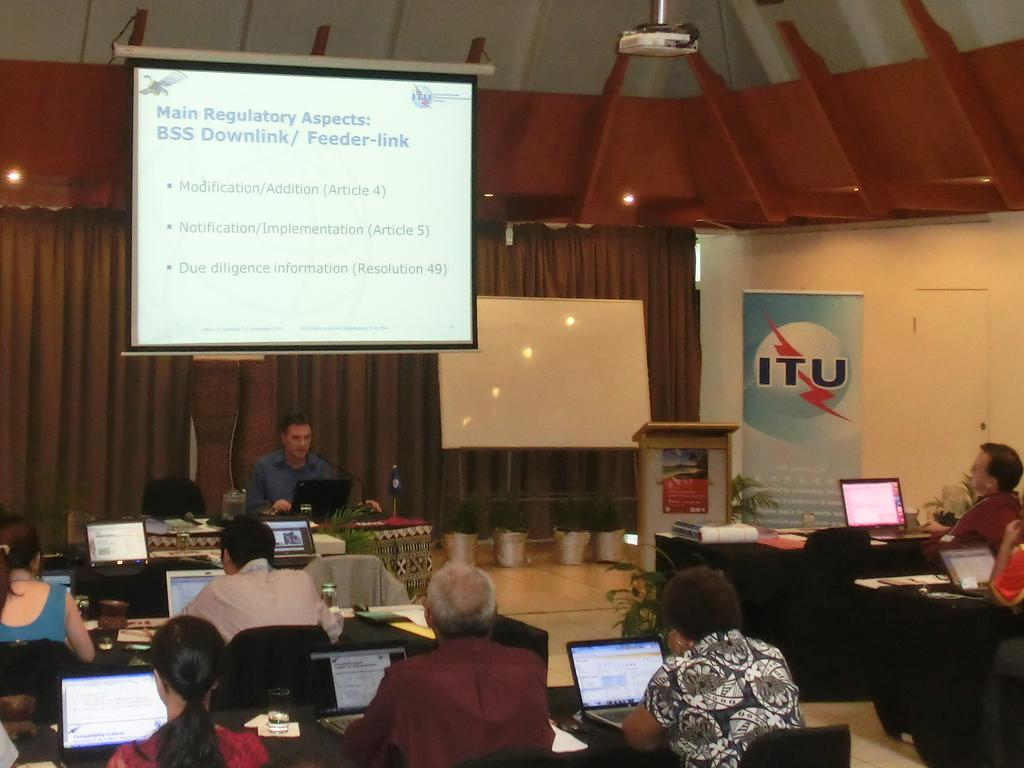Provide a one-sentence caption for the provided image. Lecture attendees at ITU work on their laptops as a speaker addresses them. 